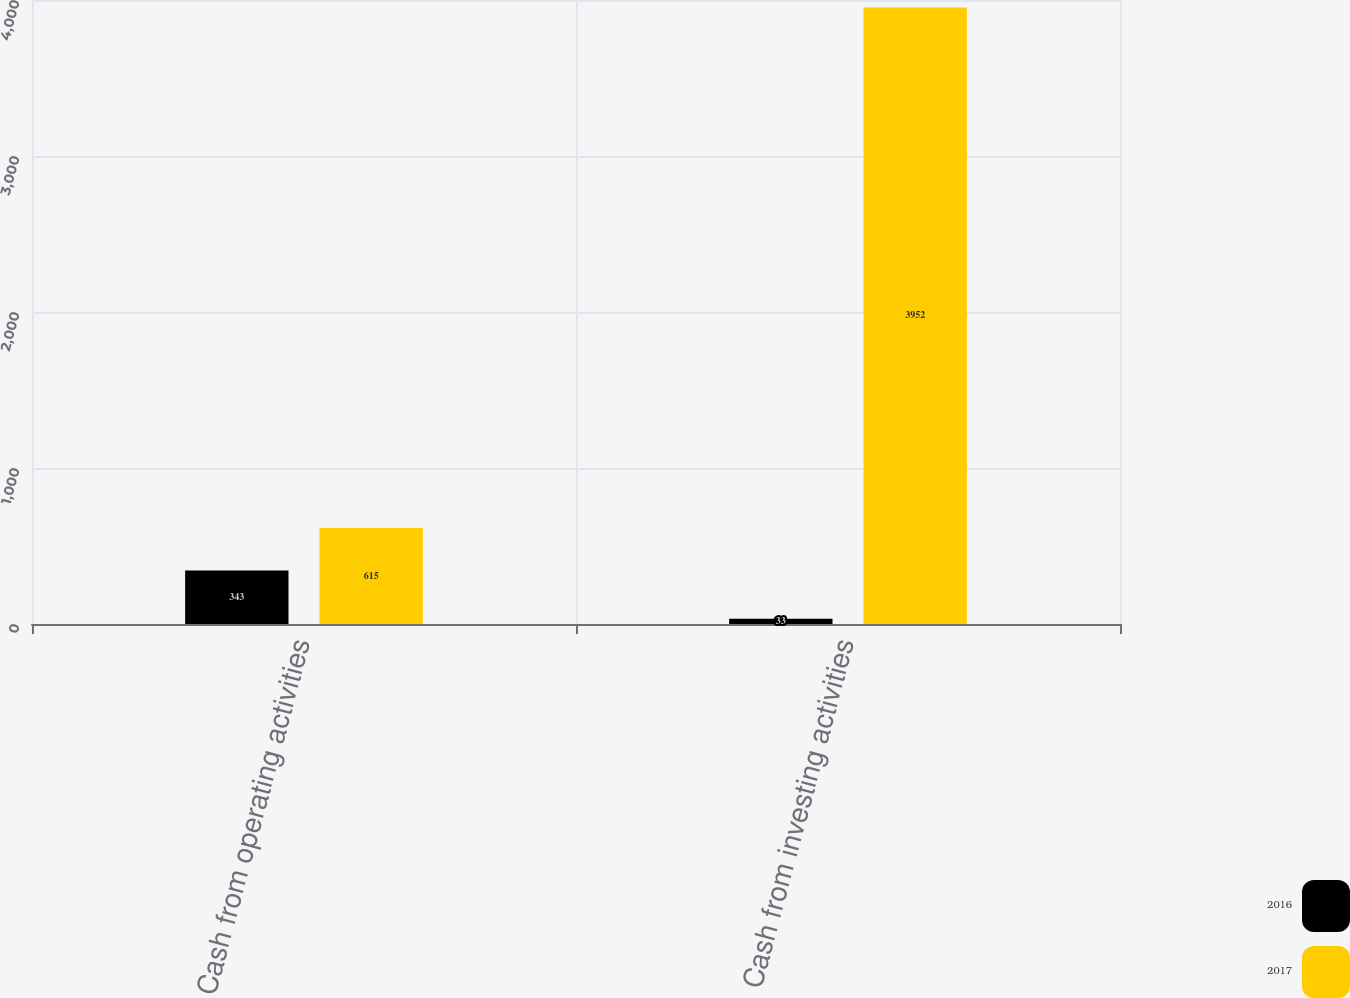<chart> <loc_0><loc_0><loc_500><loc_500><stacked_bar_chart><ecel><fcel>Cash from operating activities<fcel>Cash from investing activities<nl><fcel>2016<fcel>343<fcel>33<nl><fcel>2017<fcel>615<fcel>3952<nl></chart> 